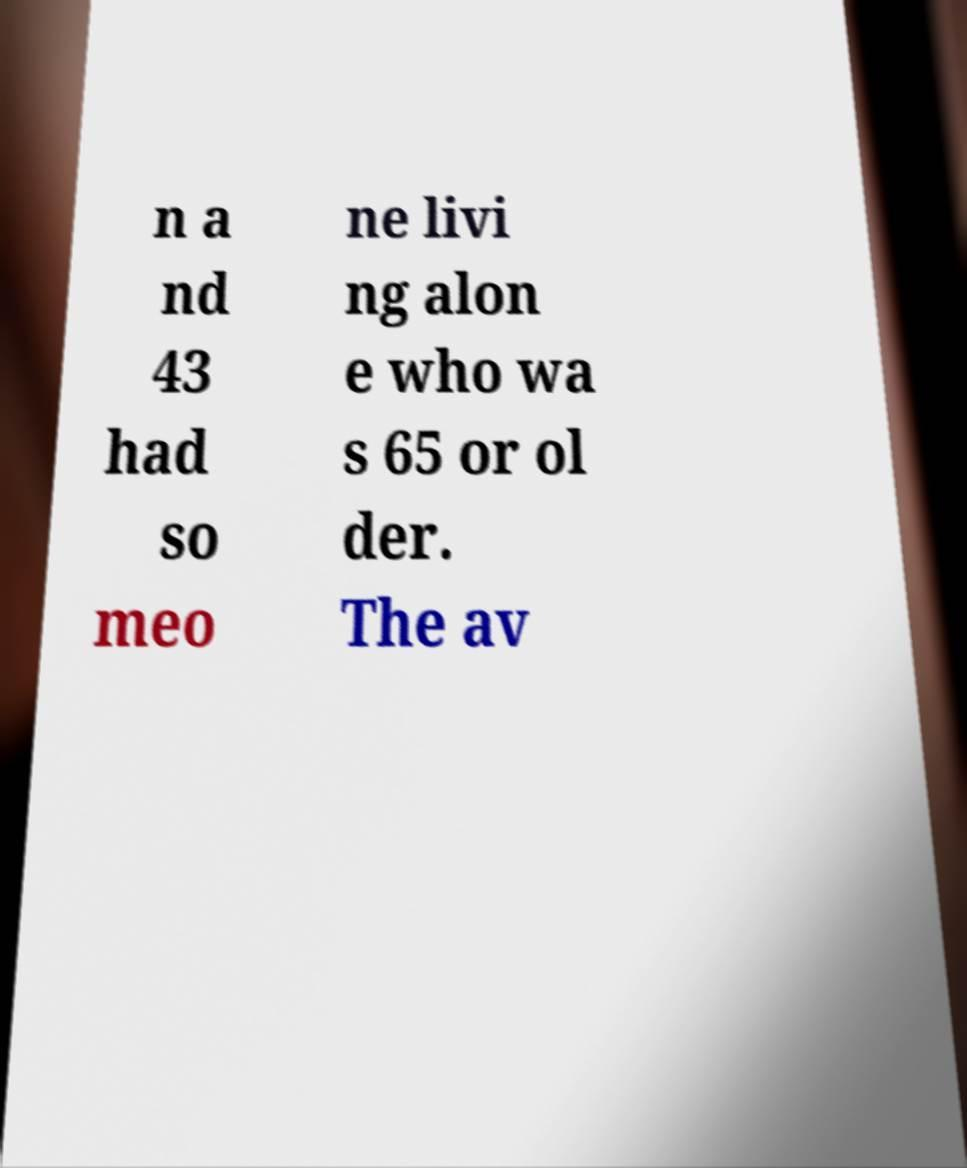Could you assist in decoding the text presented in this image and type it out clearly? n a nd 43 had so meo ne livi ng alon e who wa s 65 or ol der. The av 